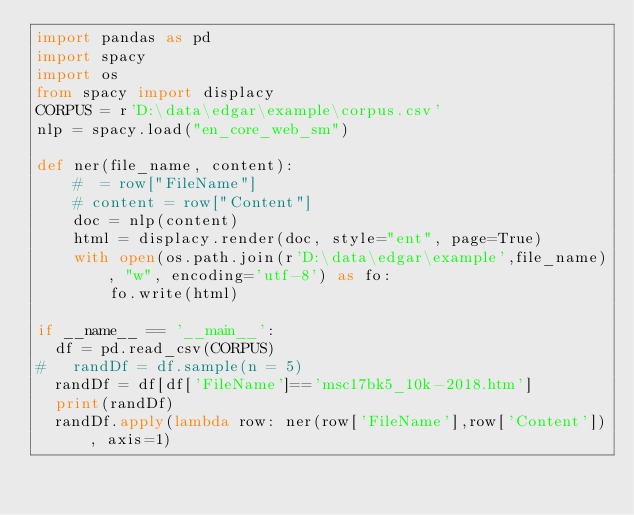<code> <loc_0><loc_0><loc_500><loc_500><_Python_>import pandas as pd
import spacy
import os
from spacy import displacy
CORPUS = r'D:\data\edgar\example\corpus.csv'
nlp = spacy.load("en_core_web_sm")

def ner(file_name, content):
    #  = row["FileName"]
    # content = row["Content"]
    doc = nlp(content)
    html = displacy.render(doc, style="ent", page=True)
    with open(os.path.join(r'D:\data\edgar\example',file_name), "w", encoding='utf-8') as fo:
        fo.write(html)

if __name__ == '__main__':
  df = pd.read_csv(CORPUS)
#   randDf = df.sample(n = 5)
  randDf = df[df['FileName']=='msc17bk5_10k-2018.htm']
  print(randDf)
  randDf.apply(lambda row: ner(row['FileName'],row['Content']), axis=1)

</code> 